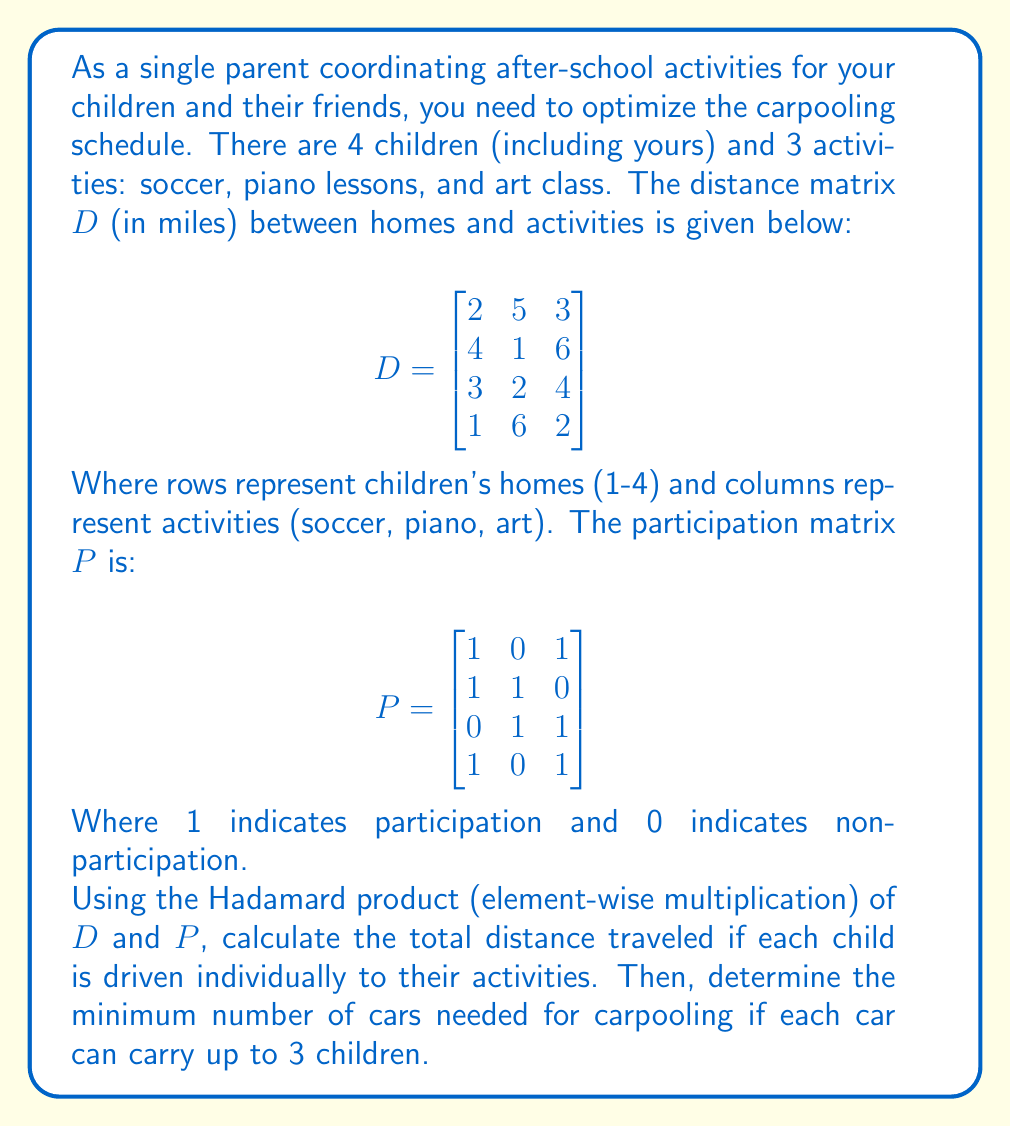Can you answer this question? Let's approach this step-by-step:

1) First, we need to calculate the Hadamard product of $D$ and $P$. This will give us a matrix where each element represents the distance traveled for a child to an activity they participate in, or 0 if they don't participate.

   $$D \circ P = \begin{bmatrix}
   2\cdot1 & 5\cdot0 & 3\cdot1 \\
   4\cdot1 & 1\cdot1 & 6\cdot0 \\
   3\cdot0 & 2\cdot1 & 4\cdot1 \\
   1\cdot1 & 6\cdot0 & 2\cdot1
   \end{bmatrix} = \begin{bmatrix}
   2 & 0 & 3 \\
   4 & 1 & 0 \\
   0 & 2 & 4 \\
   1 & 0 & 2
   \end{bmatrix}$$

2) To calculate the total distance traveled, we sum all elements of this matrix:

   Total distance = 2 + 0 + 3 + 4 + 1 + 0 + 0 + 2 + 4 + 1 + 0 + 2 = 19 miles

3) To determine the minimum number of cars needed for carpooling, we need to look at the number of children attending each activity:

   Soccer: 3 children (rows 1, 2, and 4)
   Piano: 2 children (rows 2 and 3)
   Art: 3 children (rows 1, 3, and 4)

4) Since each car can carry up to 3 children, we need:
   - 1 car for soccer
   - 1 car for piano
   - 1 car for art

Therefore, the minimum number of cars needed is 3.
Answer: 19 miles; 3 cars 